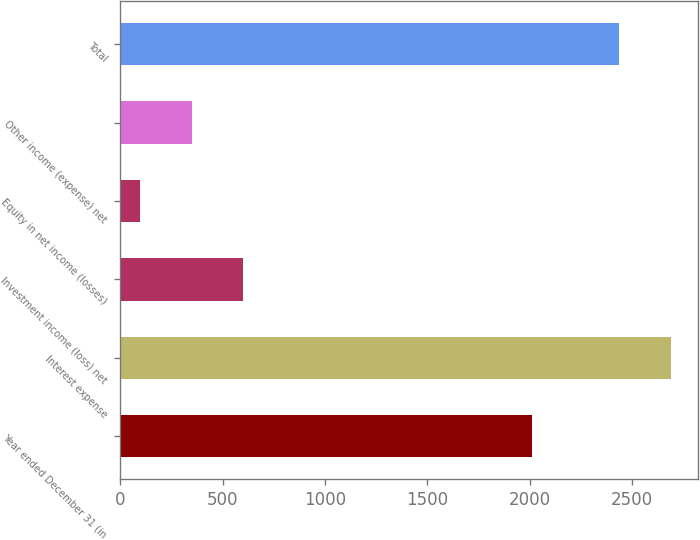Convert chart to OTSL. <chart><loc_0><loc_0><loc_500><loc_500><bar_chart><fcel>Year ended December 31 (in<fcel>Interest expense<fcel>Investment income (loss) net<fcel>Equity in net income (losses)<fcel>Other income (expense) net<fcel>Total<nl><fcel>2014<fcel>2691<fcel>601<fcel>97<fcel>349<fcel>2439<nl></chart> 